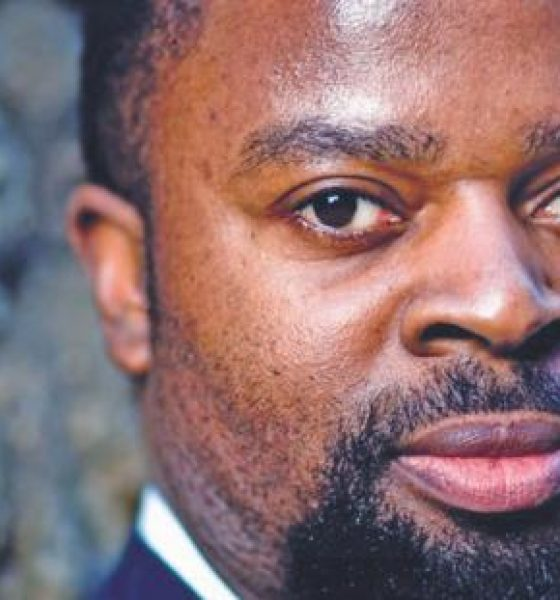Imagine this person is a character in a fictional story. Describe their background and current situation. In a fictional story, this individual could be a high-powered corporate executive leading a multinational firm through turbulent times. With a background in law and a master's in business administration, they have climbed the corporate ladder through sheer perseverance and hard work. In the current situation, they are navigating a critical merger that could define their career and the company's future. Their composed and serious demeanor, as seen in the photograph, reflects their deep commitment to success and their readiness to face challenges head-on. 